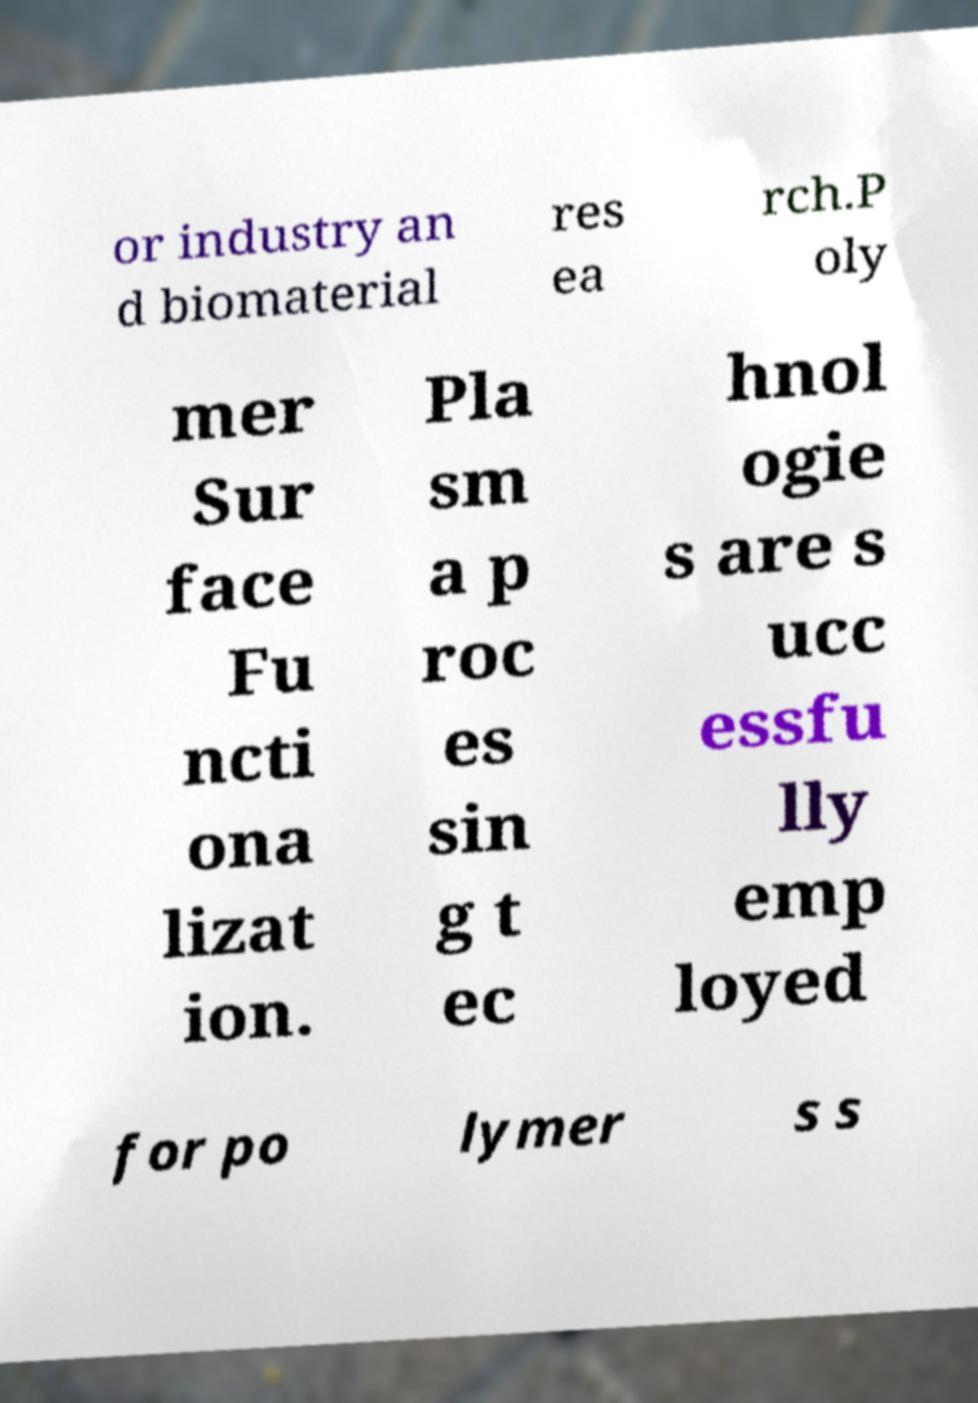Can you accurately transcribe the text from the provided image for me? or industry an d biomaterial res ea rch.P oly mer Sur face Fu ncti ona lizat ion. Pla sm a p roc es sin g t ec hnol ogie s are s ucc essfu lly emp loyed for po lymer s s 